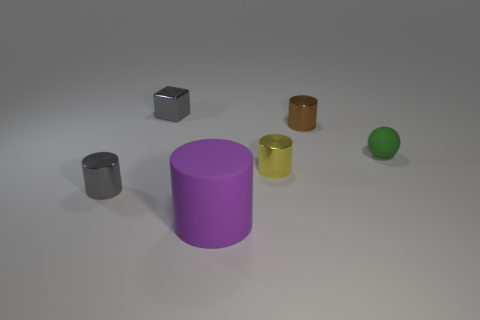What size is the purple object?
Make the answer very short. Large. How many brown metallic cylinders are the same size as the matte ball?
Provide a short and direct response. 1. Is the cylinder behind the small yellow cylinder made of the same material as the cylinder left of the large cylinder?
Keep it short and to the point. Yes. Is the number of tiny green balls greater than the number of large purple metal spheres?
Offer a terse response. Yes. Is there anything else that has the same color as the large object?
Your answer should be compact. No. Does the gray block have the same material as the tiny yellow cylinder?
Your response must be concise. Yes. Is the number of tiny brown metal cylinders less than the number of small objects?
Offer a terse response. Yes. Do the tiny rubber thing and the tiny brown metallic object have the same shape?
Give a very brief answer. No. What color is the ball?
Keep it short and to the point. Green. How many other things are there of the same material as the tiny brown object?
Offer a very short reply. 3. 